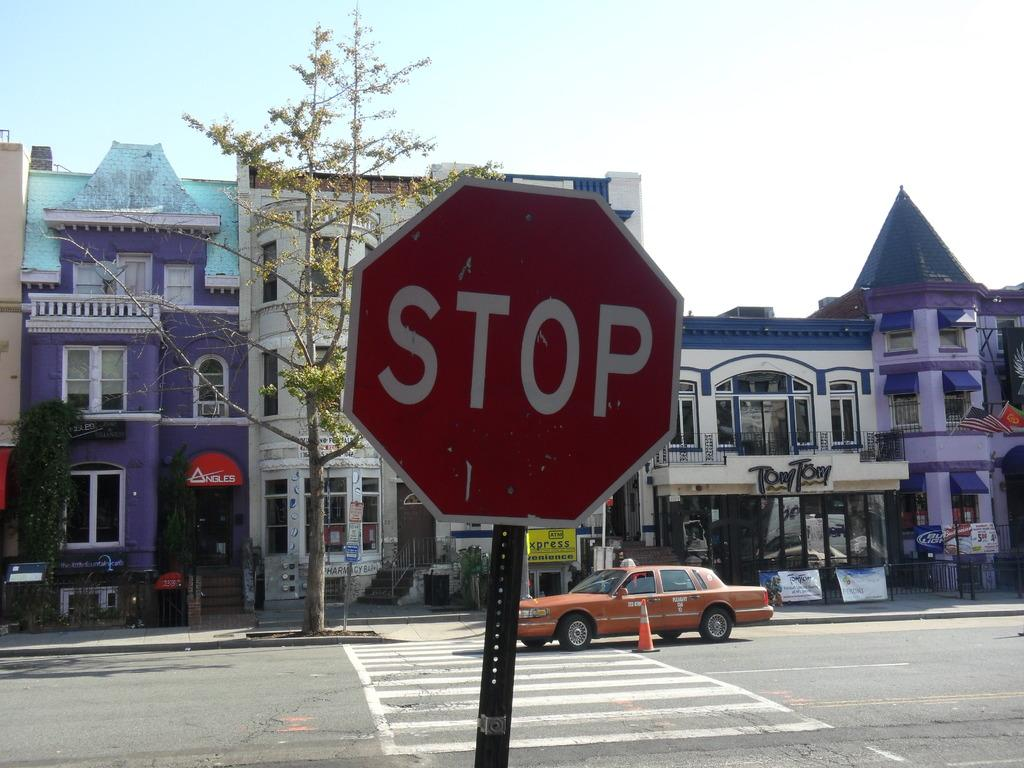<image>
Render a clear and concise summary of the photo. A large red sign says Stop and a brown car is driving in the background. 